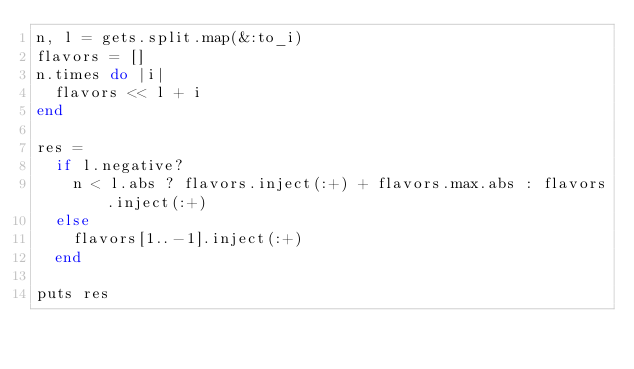Convert code to text. <code><loc_0><loc_0><loc_500><loc_500><_Ruby_>n, l = gets.split.map(&:to_i)
flavors = []
n.times do |i|
  flavors << l + i
end

res =
  if l.negative?
    n < l.abs ? flavors.inject(:+) + flavors.max.abs : flavors.inject(:+)
  else
    flavors[1..-1].inject(:+)
  end

puts res
</code> 